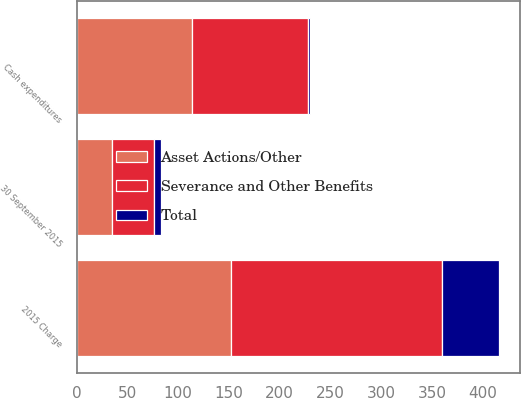<chart> <loc_0><loc_0><loc_500><loc_500><stacked_bar_chart><ecel><fcel>2015 Charge<fcel>Cash expenditures<fcel>30 September 2015<nl><fcel>Asset Actions/Other<fcel>151.9<fcel>113.5<fcel>34.5<nl><fcel>Total<fcel>55.8<fcel>1.2<fcel>7.2<nl><fcel>Severance and Other Benefits<fcel>207.7<fcel>114.7<fcel>41.7<nl></chart> 